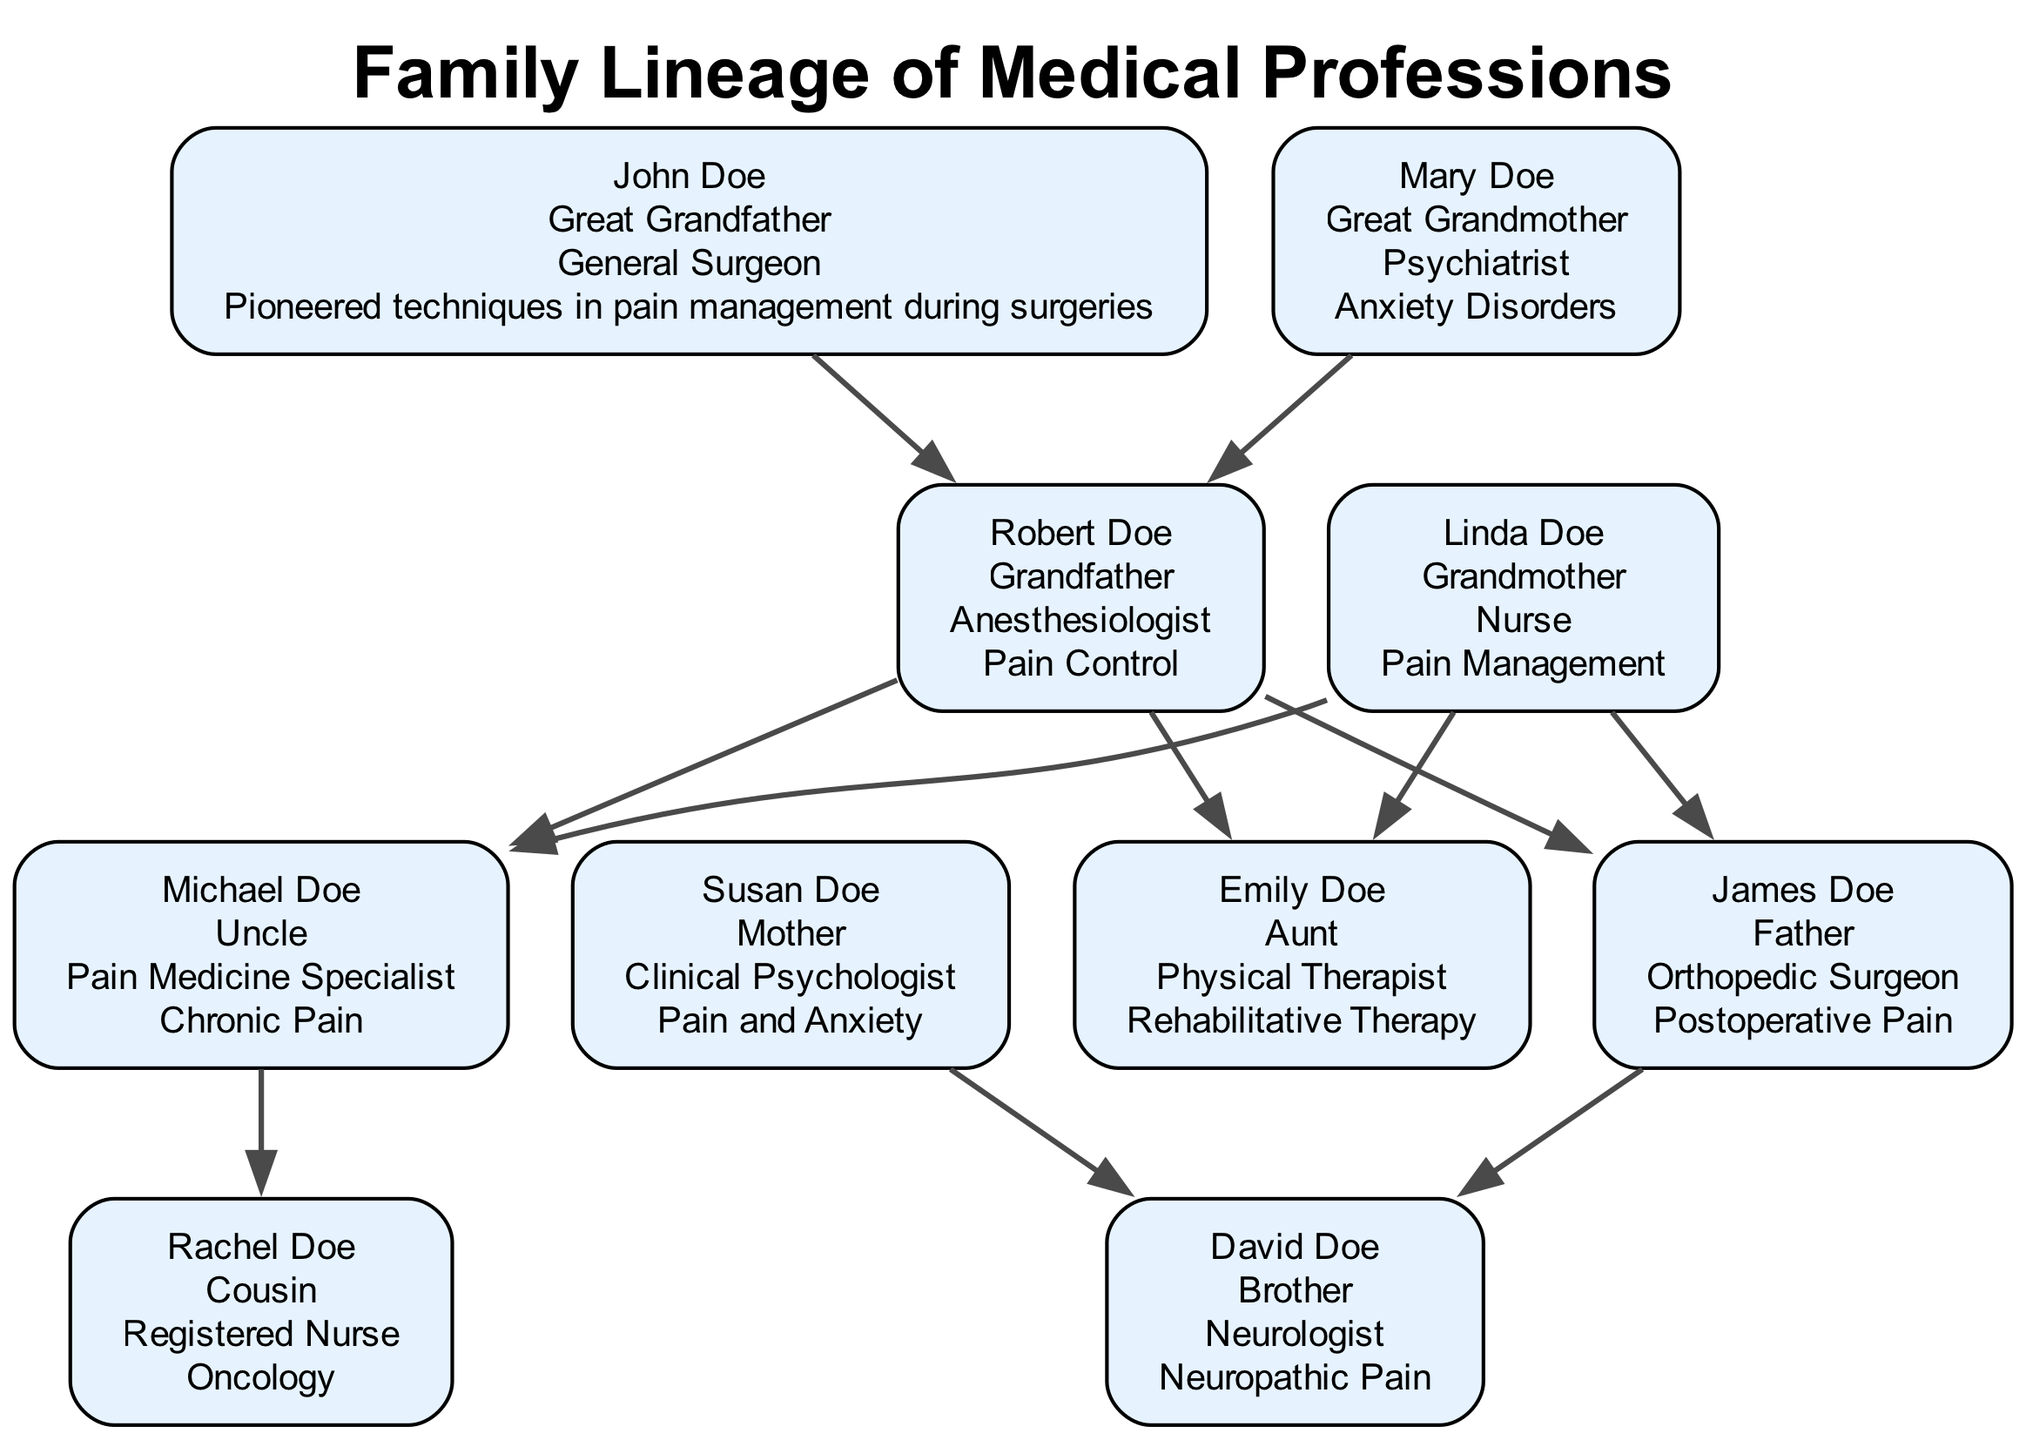What is the profession of John Doe? John Doe is labeled as a "General Surgeon" in the diagram. This information is presented directly in his node.
Answer: General Surgeon Who is the great grandmother in the family tree? The node for the great grandmother shows "Mary Doe," which is the name positioned as the great grandmother.
Answer: Mary Doe How many nodes are there for medical professionals in the family tree? By counting each unique member depicted in the diagram, we find there are 10 distinct nodes representing medical professionals.
Answer: 10 Which family member specializes in pain control? Referring to the diagram, the node for "Robert Doe" explicitly states that he is an "Anesthesiologist" with a specialty in "Pain Control."
Answer: Robert Doe What relationship do Emily Doe and David Doe have? The relationships in the diagram indicate that both "Emily Doe" and "David Doe" are children of "James Doe" and "Susan Doe," making them siblings.
Answer: Siblings Which family member contributes to anxiety disorders? The node for "Mary Doe" highlights her profession as a "Psychiatrist" and specifies her specialty in "Anxiety Disorders," showing her contribution.
Answer: Mary Doe How many surgeons are featured in the family tree? The diagram lists "John Doe" as a General Surgeon and "James Doe" as an Orthopedic Surgeon; thus, we add these two to find there are two surgeons.
Answer: 2 What is Susan Doe's specialty area? Looking at Susan Doe's node, she is noted to be a "Clinical Psychologist" with a specialty in "Pain and Anxiety."
Answer: Pain and Anxiety Which individual developed a multidisciplinary approach to chronic pain? In the diagram, "Michael Doe" is labeled as a "Pain Medicine Specialist," and his contributions cite leading a multidisciplinary team for pain management.
Answer: Michael Doe 